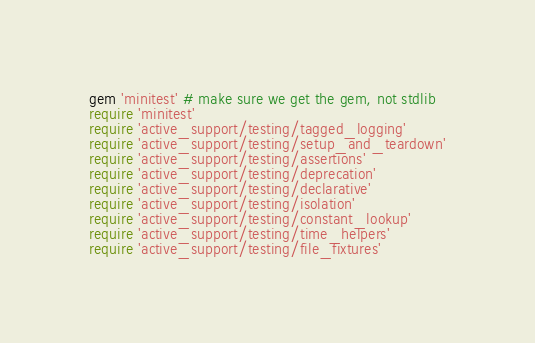Convert code to text. <code><loc_0><loc_0><loc_500><loc_500><_Ruby_>gem 'minitest' # make sure we get the gem, not stdlib
require 'minitest'
require 'active_support/testing/tagged_logging'
require 'active_support/testing/setup_and_teardown'
require 'active_support/testing/assertions'
require 'active_support/testing/deprecation'
require 'active_support/testing/declarative'
require 'active_support/testing/isolation'
require 'active_support/testing/constant_lookup'
require 'active_support/testing/time_helpers'
require 'active_support/testing/file_fixtures'</code> 